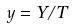Convert formula to latex. <formula><loc_0><loc_0><loc_500><loc_500>y = Y / T</formula> 